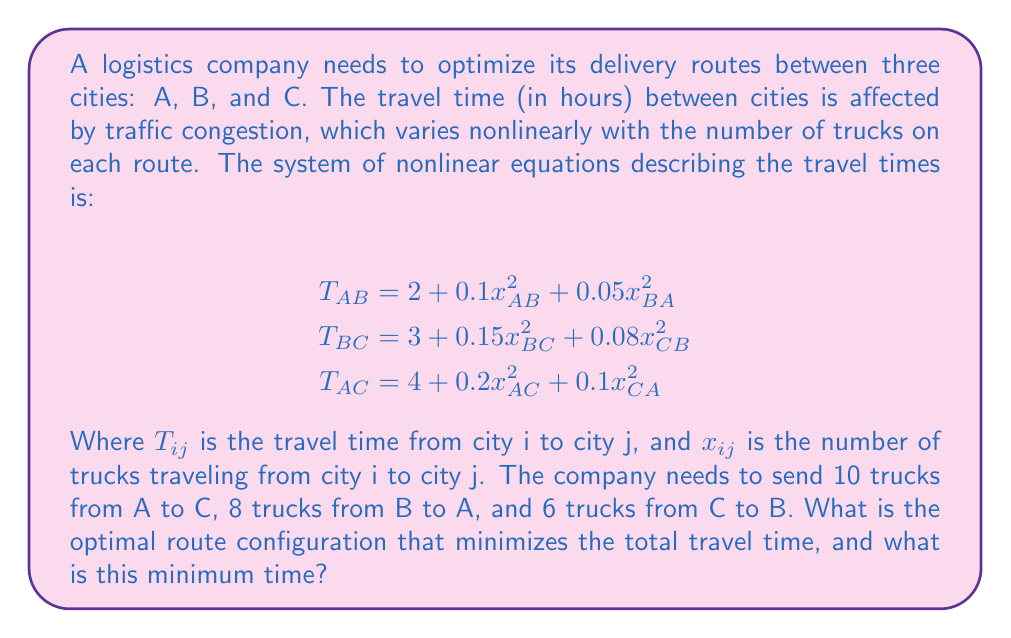Help me with this question. To solve this problem, we need to consider all possible route configurations and calculate the total travel time for each. The optimal route will be the one with the minimum total time.

Step 1: Identify possible routes
- Route 1: A → C (direct)
- Route 2: A → B → C
- Route 3: A → B → A → C

Step 2: Calculate travel times for each route

Route 1: A → C (direct)
$x_{AC} = 10, x_{CA} = 0$
$T_{AC} = 4 + 0.2(10)^2 + 0.1(0)^2 = 24$ hours

Route 2: A → B → C
$x_{AB} = 10, x_{BA} = 8, x_{BC} = 10, x_{CB} = 6$
$T_{AB} = 2 + 0.1(10)^2 + 0.05(8)^2 = 14.2$ hours
$T_{BC} = 3 + 0.15(10)^2 + 0.08(6)^2 = 18.88$ hours
Total time = $14.2 + 18.88 = 33.08$ hours

Route 3: A → B → A → C
$x_{AB} = 10, x_{BA} = 8, x_{AC} = 10, x_{CA} = 0$
$T_{AB} = 2 + 0.1(10)^2 + 0.05(8)^2 = 14.2$ hours
$T_{BA} = 2 + 0.1(8)^2 + 0.05(10)^2 = 8.4$ hours
$T_{AC} = 4 + 0.2(10)^2 + 0.1(0)^2 = 24$ hours
Total time = $14.2 + 8.4 + 24 = 46.6$ hours

Step 3: Compare total travel times
Route 1: 24 hours
Route 2: 33.08 hours
Route 3: 46.6 hours

The optimal route configuration is Route 1 (A → C direct), with a minimum total travel time of 24 hours.
Answer: Optimal route: A → C (direct); Minimum time: 24 hours 